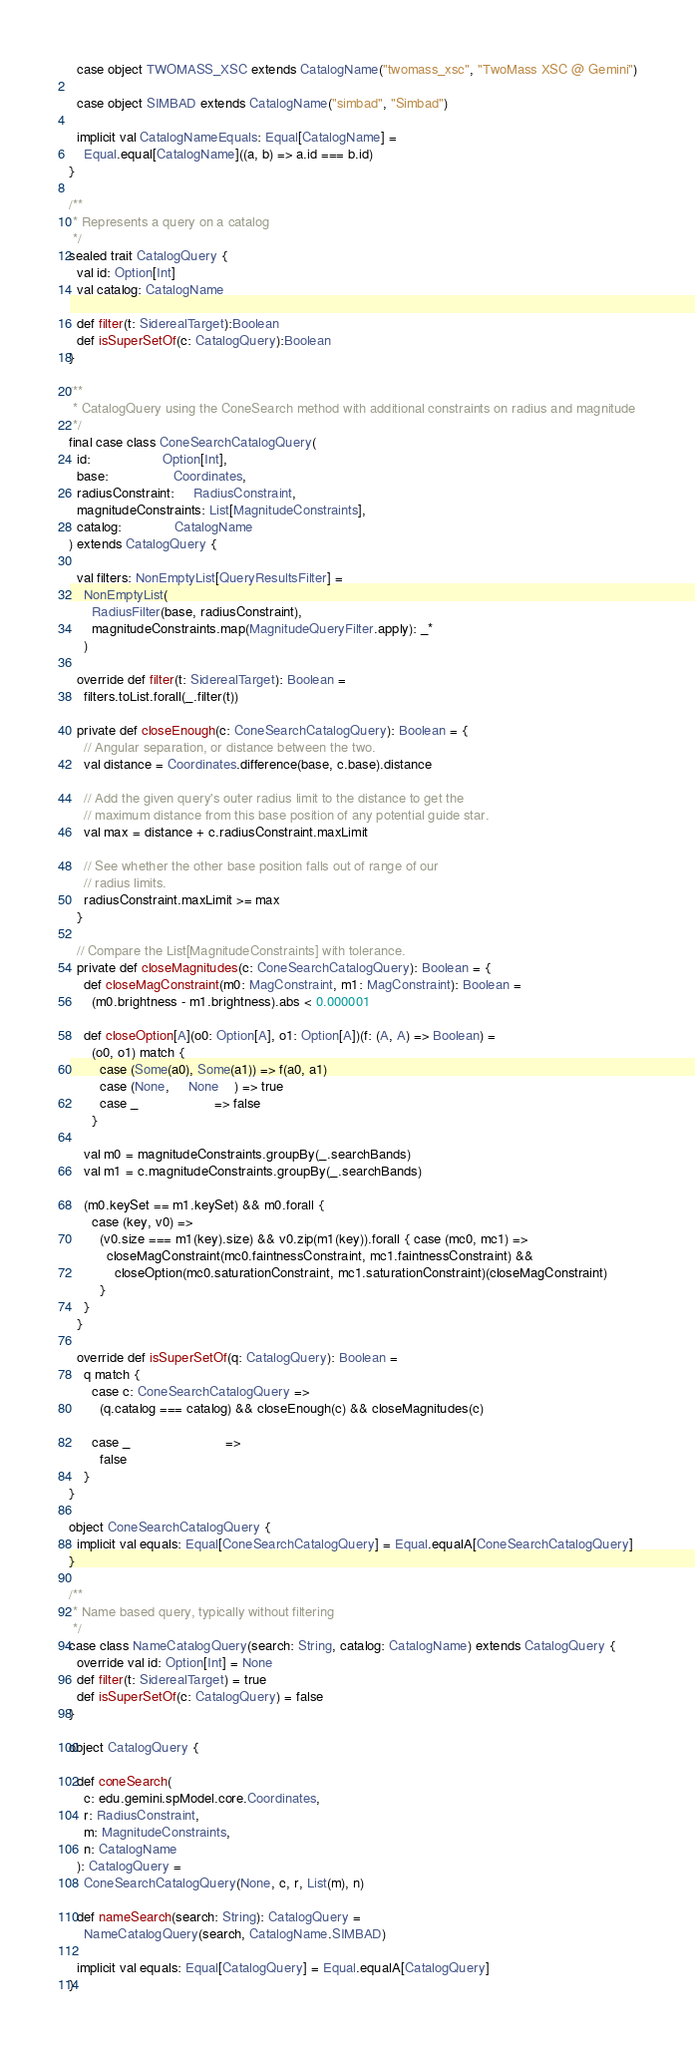<code> <loc_0><loc_0><loc_500><loc_500><_Scala_>  case object TWOMASS_XSC extends CatalogName("twomass_xsc", "TwoMass XSC @ Gemini")

  case object SIMBAD extends CatalogName("simbad", "Simbad")

  implicit val CatalogNameEquals: Equal[CatalogName] =
    Equal.equal[CatalogName]((a, b) => a.id === b.id)
}

/**
 * Represents a query on a catalog
 */
sealed trait CatalogQuery {
  val id: Option[Int]
  val catalog: CatalogName

  def filter(t: SiderealTarget):Boolean
  def isSuperSetOf(c: CatalogQuery):Boolean
}

/**
 * CatalogQuery using the ConeSearch method with additional constraints on radius and magnitude
 */
final case class ConeSearchCatalogQuery(
  id:                   Option[Int],
  base:                 Coordinates,
  radiusConstraint:     RadiusConstraint,
  magnitudeConstraints: List[MagnitudeConstraints],
  catalog:              CatalogName
) extends CatalogQuery {

  val filters: NonEmptyList[QueryResultsFilter] =
    NonEmptyList(
      RadiusFilter(base, radiusConstraint),
      magnitudeConstraints.map(MagnitudeQueryFilter.apply): _*
    )

  override def filter(t: SiderealTarget): Boolean =
    filters.toList.forall(_.filter(t))

  private def closeEnough(c: ConeSearchCatalogQuery): Boolean = {
    // Angular separation, or distance between the two.
    val distance = Coordinates.difference(base, c.base).distance

    // Add the given query's outer radius limit to the distance to get the
    // maximum distance from this base position of any potential guide star.
    val max = distance + c.radiusConstraint.maxLimit

    // See whether the other base position falls out of range of our
    // radius limits.
    radiusConstraint.maxLimit >= max
  }

  // Compare the List[MagnitudeConstraints] with tolerance.
  private def closeMagnitudes(c: ConeSearchCatalogQuery): Boolean = {
    def closeMagConstraint(m0: MagConstraint, m1: MagConstraint): Boolean =
      (m0.brightness - m1.brightness).abs < 0.000001

    def closeOption[A](o0: Option[A], o1: Option[A])(f: (A, A) => Boolean) =
      (o0, o1) match {
        case (Some(a0), Some(a1)) => f(a0, a1)
        case (None,     None    ) => true
        case _                    => false
      }

    val m0 = magnitudeConstraints.groupBy(_.searchBands)
    val m1 = c.magnitudeConstraints.groupBy(_.searchBands)

    (m0.keySet == m1.keySet) && m0.forall {
      case (key, v0) =>
        (v0.size === m1(key).size) && v0.zip(m1(key)).forall { case (mc0, mc1) =>
          closeMagConstraint(mc0.faintnessConstraint, mc1.faintnessConstraint) &&
            closeOption(mc0.saturationConstraint, mc1.saturationConstraint)(closeMagConstraint)
        }
    }
  }

  override def isSuperSetOf(q: CatalogQuery): Boolean =
    q match {
      case c: ConeSearchCatalogQuery =>
        (q.catalog === catalog) && closeEnough(c) && closeMagnitudes(c)

      case _                         =>
        false
    }
}

object ConeSearchCatalogQuery {
  implicit val equals: Equal[ConeSearchCatalogQuery] = Equal.equalA[ConeSearchCatalogQuery]
}

/**
 * Name based query, typically without filtering
 */
case class NameCatalogQuery(search: String, catalog: CatalogName) extends CatalogQuery {
  override val id: Option[Int] = None
  def filter(t: SiderealTarget) = true
  def isSuperSetOf(c: CatalogQuery) = false
}

object CatalogQuery {

  def coneSearch(
    c: edu.gemini.spModel.core.Coordinates,
    r: RadiusConstraint,
    m: MagnitudeConstraints,
    n: CatalogName
  ): CatalogQuery =
    ConeSearchCatalogQuery(None, c, r, List(m), n)

  def nameSearch(search: String): CatalogQuery =
    NameCatalogQuery(search, CatalogName.SIMBAD)

  implicit val equals: Equal[CatalogQuery] = Equal.equalA[CatalogQuery]
}
</code> 